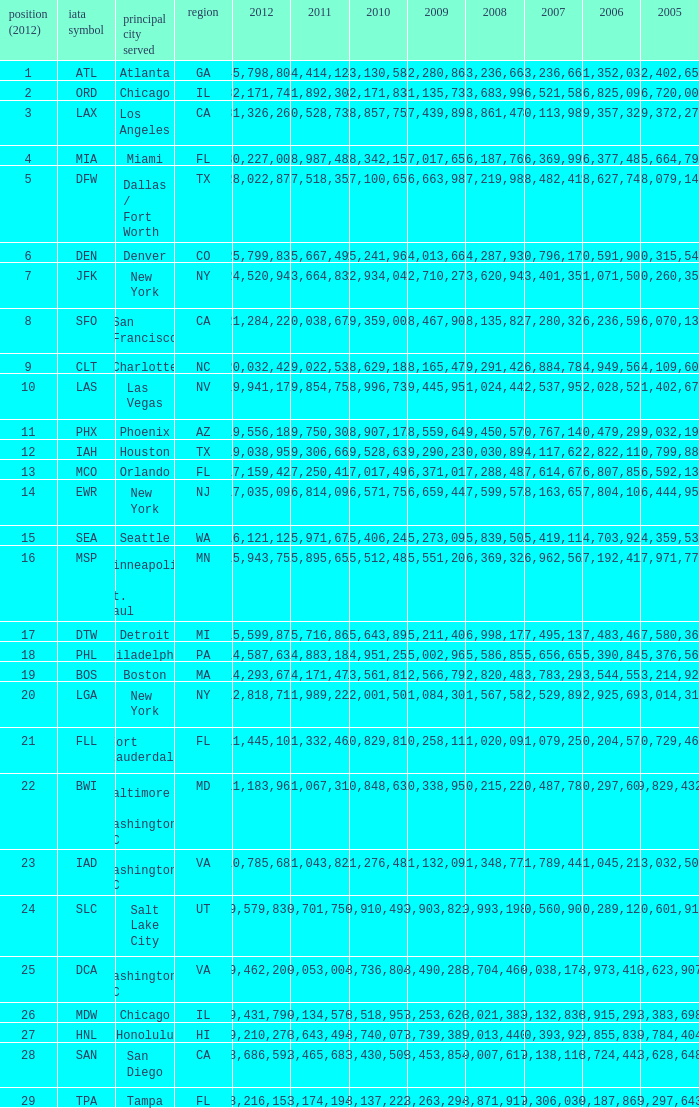What is the greatest 2010 for Miami, Fl? 28342158.0. 